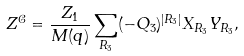Convert formula to latex. <formula><loc_0><loc_0><loc_500><loc_500>Z ^ { \mathcal { C } } = \frac { Z _ { 1 } } { M ( q ) } \sum _ { R _ { 3 } } ( - Q _ { 3 } ) ^ { | R _ { 3 } | } X _ { R _ { 3 } } Y _ { R _ { 3 } } ,</formula> 